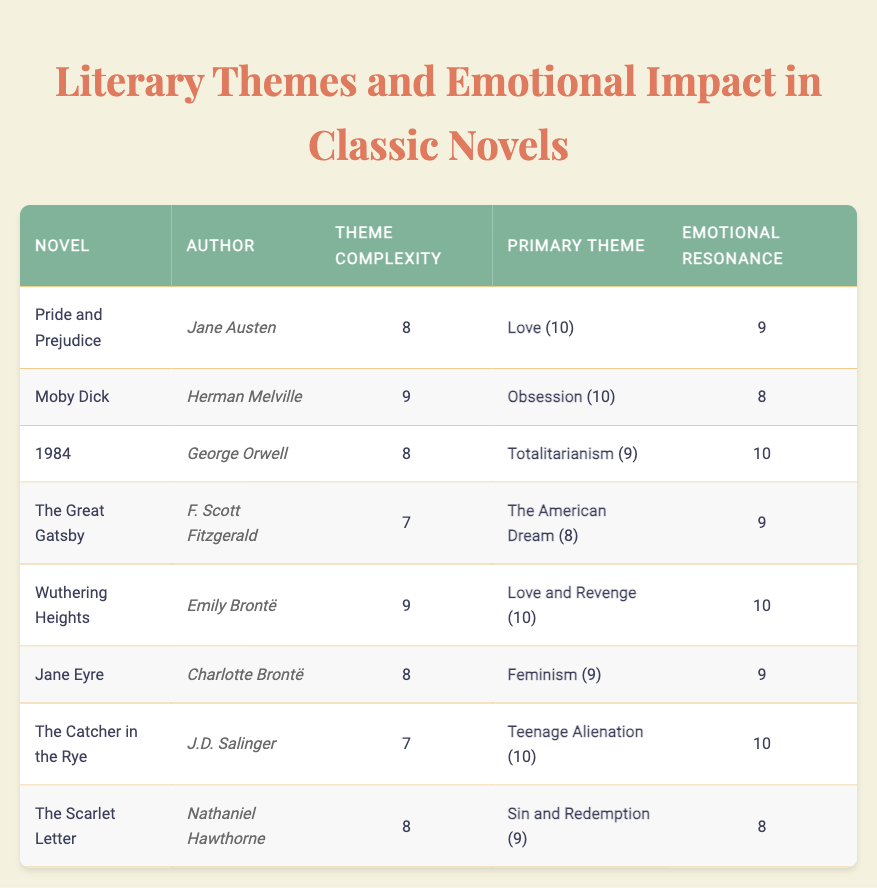What is the emotional resonance score of "Wuthering Heights"? The table indicates that the emotional resonance score for "Wuthering Heights" is 10.
Answer: 10 Which novel has the highest theme complexity? "Moby Dick" and "Wuthering Heights" both have the highest theme complexity score of 9, but since they share the same score, we can conclude that they are tied for the highest.
Answer: Moby Dick and Wuthering Heights Is the emotional resonance score for "1984" greater than the average emotional resonance score of the novels listed? The emotional resonance scores are 9, 8, 10, 9, 10, 9, 10, and 8 for the respective novels. The average is (9 + 8 + 10 + 9 + 10 + 9 + 10 + 8) / 8 = 9. Therefore, yes, the score for "1984" (10) is higher than the average emotional resonance score.
Answer: Yes What is the primary theme of "The Scarlet Letter" and its score? The primary theme of "The Scarlet Letter" is "Sin and Redemption," which has a score of 9 according to the table.
Answer: Sin and Redemption (9) Which novel has the lowest theme complexity score? "The Great Gatsby" has the lowest theme complexity score of 7 as compared to the other novels listed.
Answer: The Great Gatsby 